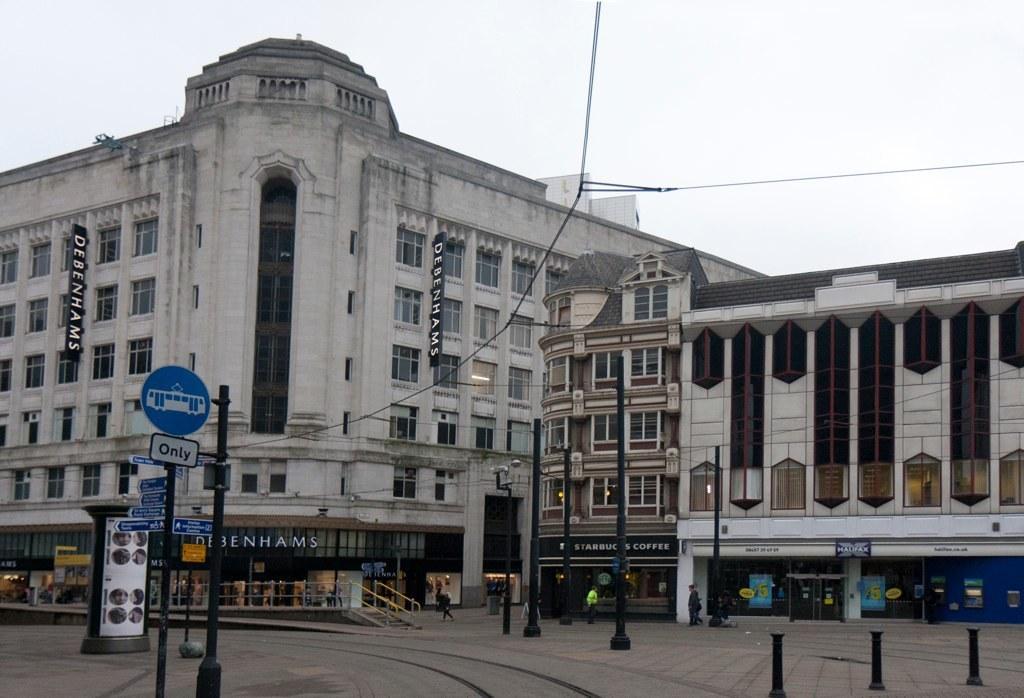Could you give a brief overview of what you see in this image? In this picture we can see the buildings, windows, boards, poles, stores, stairs and some persons. At the top of the image we can see the sky and wires. At the bottom of the image we can see the road. 